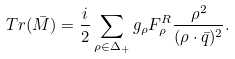Convert formula to latex. <formula><loc_0><loc_0><loc_500><loc_500>T r ( \bar { M } ) = \frac { i } { 2 } \sum _ { \rho \in \Delta _ { + } } g _ { \rho } F _ { \rho } ^ { R } \frac { \rho ^ { 2 } } { ( \rho \cdot \bar { q } ) ^ { 2 } } .</formula> 